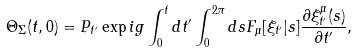<formula> <loc_0><loc_0><loc_500><loc_500>\Theta _ { \Sigma } ( t , 0 ) = P _ { t ^ { \prime } } \exp i g \int _ { 0 } ^ { t } d t ^ { \prime } \int _ { 0 } ^ { 2 \pi } d s F _ { \mu } [ \xi _ { t ^ { \prime } } | s ] \frac { \partial \xi _ { t ^ { \prime } } ^ { \mu } ( s ) } { \partial t ^ { \prime } } ,</formula> 